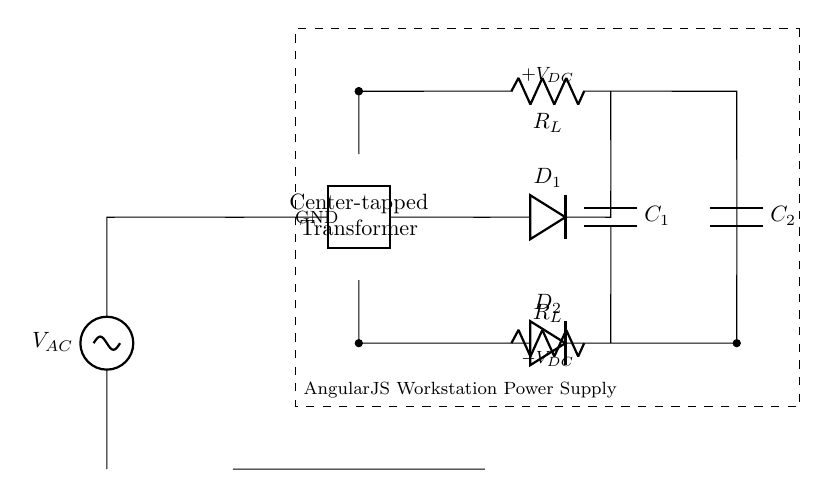What type of transformer is used in the circuit? The circuit uses a center-tapped transformer, which is indicated in the diagram as a two-port component labeled "Center-tapped Transformer". This allows for balanced DC power output from the rectification process.
Answer: center-tapped transformer How many diodes are present in the circuit? The diagram clearly shows two distinct diodes, labeled D1 and D2, connected to the outputs of the transformer, confirming the use of a full-wave rectification approach.
Answer: two What is the function of the capacitor C1? Capacitor C1 is used for smoothing the rectified output by filtering out the ripple in the DC voltage. In the circuit, it connects after the two diodes and helps to maintain a steady voltage output for the load.
Answer: smoothing What is the load resistance denoted in the circuit? The resistances in the circuit are labeled as R_L, which refers to the load resistor connected to the DC output, indicating the component where the power is delivered.
Answer: R_L What is the DC voltage output from the circuit? The circuit diagram indicates that the output produces a positive and a negative DC voltage labeled as +V_DC and -V_DC, reflecting the balance provided by the center-tapped transformer. The exact voltage levels are not specified, as they depend on the input AC voltage and transformer specifications.
Answer: +V_DC and -V_DC How is the ground referenced in the circuit? The ground is indicated in the diagram at the center-tap of the transformer, showing that it serves as the reference point for both the +V_DC and -V_DC outputs, essential for balanced DC power delivery.
Answer: GND What is the purpose of using a center-tapped transformer in this circuit? A center-tapped transformer is used to provide two equal voltages with respect to a common ground point, which permits full-wave rectification in this configuration, improving efficiency and reducing ripple voltage in the output DC.
Answer: full-wave rectification 